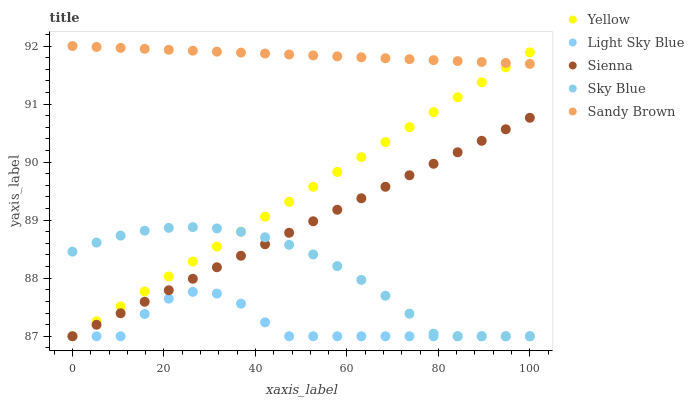Does Light Sky Blue have the minimum area under the curve?
Answer yes or no. Yes. Does Sandy Brown have the maximum area under the curve?
Answer yes or no. Yes. Does Sky Blue have the minimum area under the curve?
Answer yes or no. No. Does Sky Blue have the maximum area under the curve?
Answer yes or no. No. Is Yellow the smoothest?
Answer yes or no. Yes. Is Light Sky Blue the roughest?
Answer yes or no. Yes. Is Sky Blue the smoothest?
Answer yes or no. No. Is Sky Blue the roughest?
Answer yes or no. No. Does Sienna have the lowest value?
Answer yes or no. Yes. Does Sandy Brown have the lowest value?
Answer yes or no. No. Does Sandy Brown have the highest value?
Answer yes or no. Yes. Does Sky Blue have the highest value?
Answer yes or no. No. Is Sky Blue less than Sandy Brown?
Answer yes or no. Yes. Is Sandy Brown greater than Light Sky Blue?
Answer yes or no. Yes. Does Yellow intersect Sienna?
Answer yes or no. Yes. Is Yellow less than Sienna?
Answer yes or no. No. Is Yellow greater than Sienna?
Answer yes or no. No. Does Sky Blue intersect Sandy Brown?
Answer yes or no. No. 